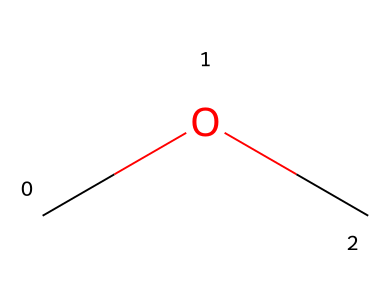What is the molecular formula of this compound? The compound shown has the SMILES representation "COC," indicating two carbon atoms (C), six hydrogen atoms (H), and one oxygen atom (O). This leads to the molecular formula being C2H6O.
Answer: C2H6O How many carbon atoms are present in this ether? The SMILES structure "COC" indicates two carbon (C) atoms are present in the compound.
Answer: 2 What type of functional group is present in this molecule? The structure "COC" signifies an ether, characterized by the presence of an oxygen atom (O) bonded to two carbon atoms (C). This aligns with the definition of ethers, which have the general structure R-O-R'.
Answer: ether What is the total number of hydrogen atoms in this compound? By analyzing the structure "COC," we see there are three hydrogens connected to each carbon (total six from two carbon atoms). Therefore, the total number of hydrogen atoms is six.
Answer: 6 What physical property is likely significant for using dimethyl ether as a fuel? Dimethyl ether (from "COC") is characterized by its low boiling point (around -24°C), which enhances its volatility and makes it suitable for combustion in heating systems.
Answer: low boiling point 